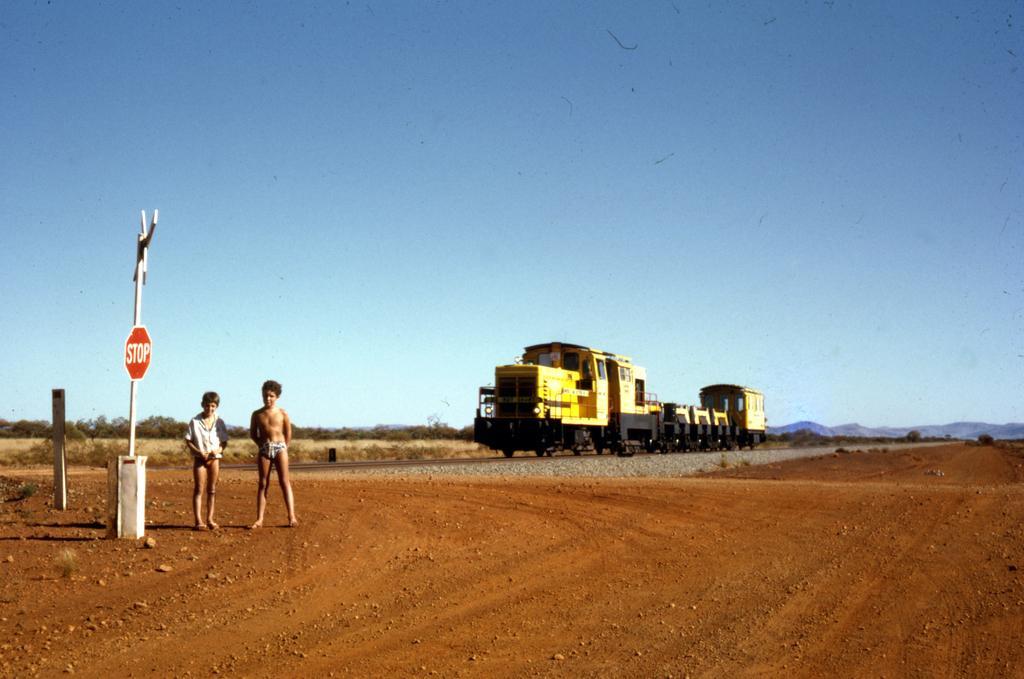In one or two sentences, can you explain what this image depicts? This picture is clicked outside. On the left we can see the two people standing on the ground and we can see the text on the board and we can see the metal rod and some other items. On the right we can see a train seems to be running on the railway track and we can see the gravel, trees and some other items. In the background we can see the sky. 